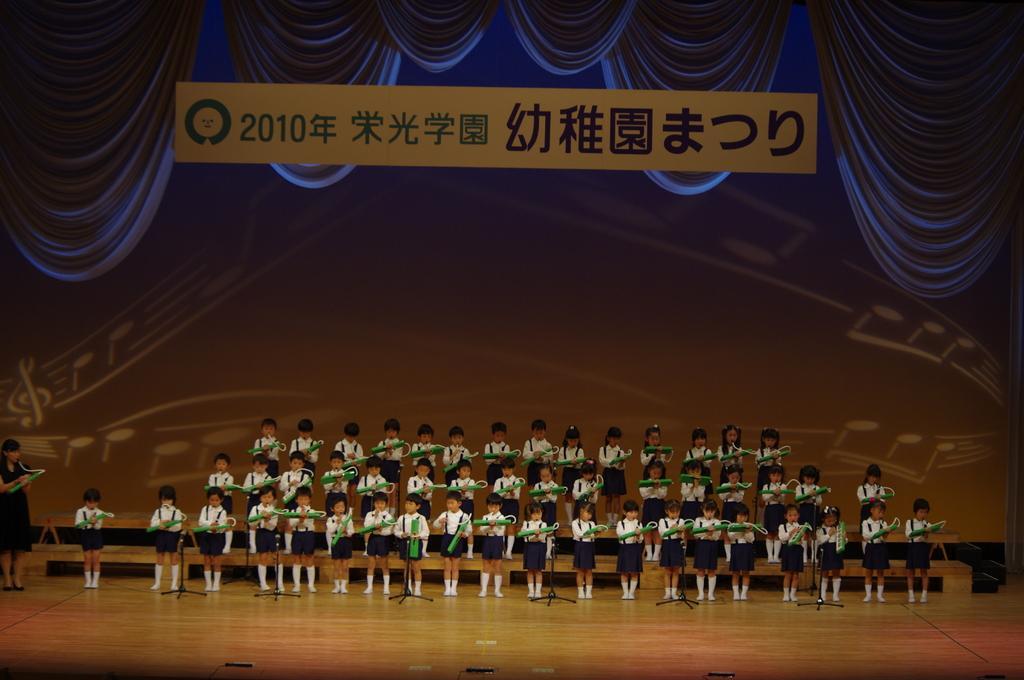In one or two sentences, can you explain what this image depicts? In this image, there are a few people holding some objects. We can see the ground and some stands. We can also see some objects at the bottom. We can see the background with some design. We can also see some curtains and some text. 